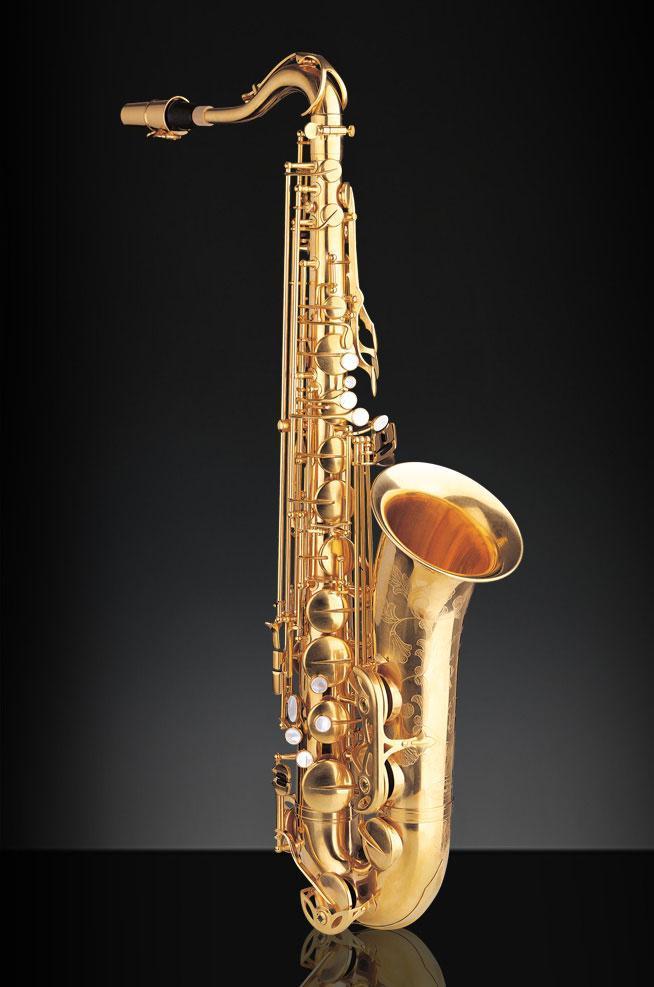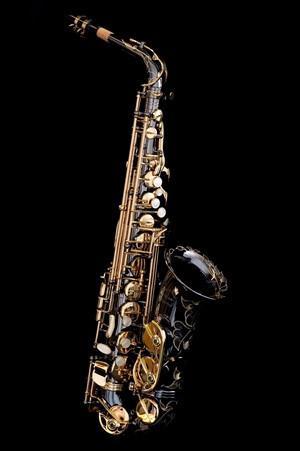The first image is the image on the left, the second image is the image on the right. Evaluate the accuracy of this statement regarding the images: "No image shows a saxophone that is tilted at greater than a 45 degree angle from vertical.". Is it true? Answer yes or no. Yes. The first image is the image on the left, the second image is the image on the right. Assess this claim about the two images: "all instruments are fully upright". Correct or not? Answer yes or no. Yes. 